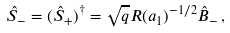<formula> <loc_0><loc_0><loc_500><loc_500>\hat { S } _ { - } = ( \hat { S } _ { + } ) ^ { \dagger } = \sqrt { q } R ( a _ { 1 } ) ^ { - 1 / 2 } \hat { B } _ { - } \, ,</formula> 